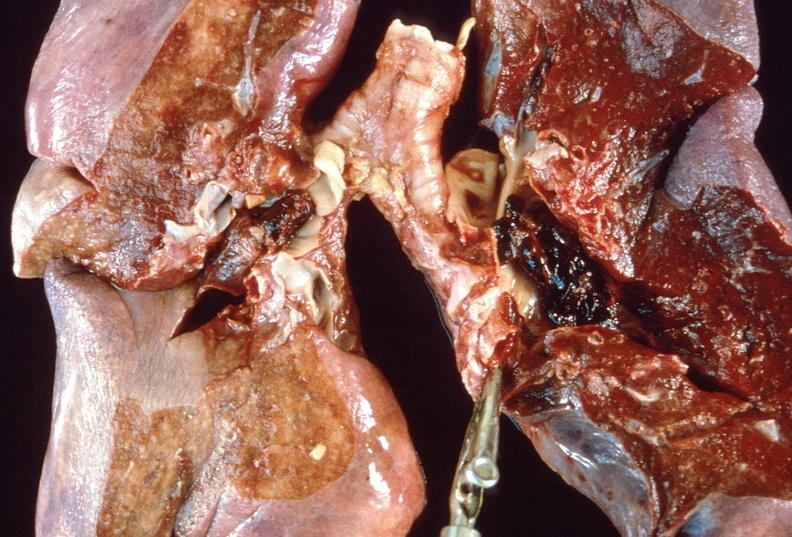s respiratory present?
Answer the question using a single word or phrase. Yes 